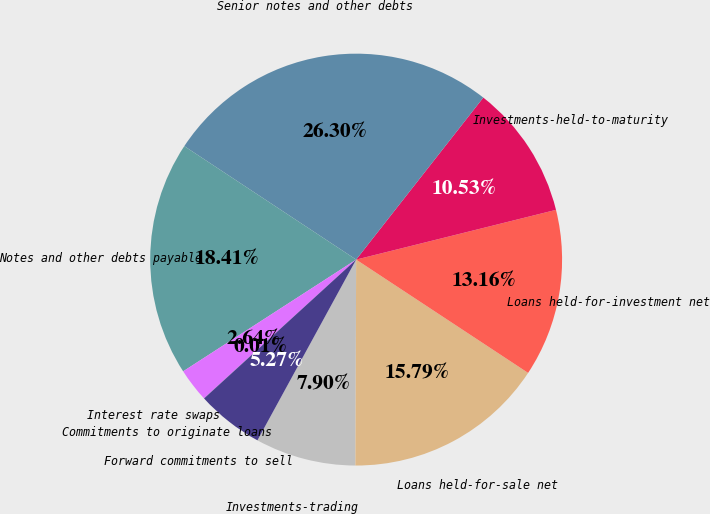Convert chart to OTSL. <chart><loc_0><loc_0><loc_500><loc_500><pie_chart><fcel>Investments-trading<fcel>Loans held-for-sale net<fcel>Loans held-for-investment net<fcel>Investments-held-to-maturity<fcel>Senior notes and other debts<fcel>Notes and other debts payable<fcel>Interest rate swaps<fcel>Commitments to originate loans<fcel>Forward commitments to sell<nl><fcel>7.9%<fcel>15.79%<fcel>13.16%<fcel>10.53%<fcel>26.31%<fcel>18.42%<fcel>2.64%<fcel>0.01%<fcel>5.27%<nl></chart> 